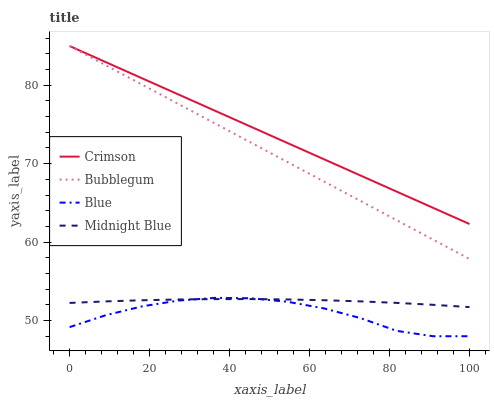Does Blue have the minimum area under the curve?
Answer yes or no. Yes. Does Crimson have the maximum area under the curve?
Answer yes or no. Yes. Does Midnight Blue have the minimum area under the curve?
Answer yes or no. No. Does Midnight Blue have the maximum area under the curve?
Answer yes or no. No. Is Bubblegum the smoothest?
Answer yes or no. Yes. Is Blue the roughest?
Answer yes or no. Yes. Is Midnight Blue the smoothest?
Answer yes or no. No. Is Midnight Blue the roughest?
Answer yes or no. No. Does Blue have the lowest value?
Answer yes or no. Yes. Does Midnight Blue have the lowest value?
Answer yes or no. No. Does Bubblegum have the highest value?
Answer yes or no. Yes. Does Blue have the highest value?
Answer yes or no. No. Is Midnight Blue less than Bubblegum?
Answer yes or no. Yes. Is Bubblegum greater than Midnight Blue?
Answer yes or no. Yes. Does Blue intersect Midnight Blue?
Answer yes or no. Yes. Is Blue less than Midnight Blue?
Answer yes or no. No. Is Blue greater than Midnight Blue?
Answer yes or no. No. Does Midnight Blue intersect Bubblegum?
Answer yes or no. No. 